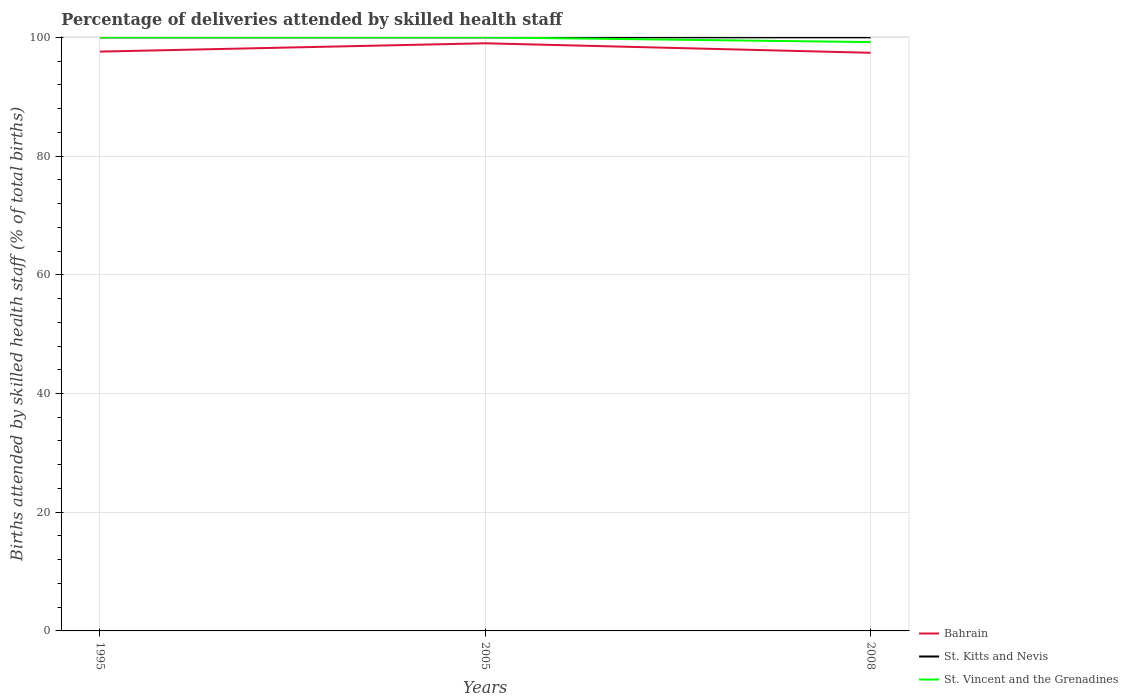How many different coloured lines are there?
Your answer should be compact. 3. Does the line corresponding to St. Kitts and Nevis intersect with the line corresponding to St. Vincent and the Grenadines?
Your answer should be compact. Yes. Across all years, what is the maximum percentage of births attended by skilled health staff in St. Vincent and the Grenadines?
Offer a terse response. 99.2. In which year was the percentage of births attended by skilled health staff in St. Vincent and the Grenadines maximum?
Ensure brevity in your answer.  2008. What is the total percentage of births attended by skilled health staff in Bahrain in the graph?
Give a very brief answer. -1.4. What is the difference between the highest and the second highest percentage of births attended by skilled health staff in St. Vincent and the Grenadines?
Keep it short and to the point. 0.8. What is the difference between the highest and the lowest percentage of births attended by skilled health staff in St. Vincent and the Grenadines?
Offer a terse response. 2. How many lines are there?
Give a very brief answer. 3. How many years are there in the graph?
Keep it short and to the point. 3. What is the difference between two consecutive major ticks on the Y-axis?
Your answer should be very brief. 20. Does the graph contain any zero values?
Ensure brevity in your answer.  No. Does the graph contain grids?
Offer a terse response. Yes. Where does the legend appear in the graph?
Your answer should be compact. Bottom right. What is the title of the graph?
Your answer should be compact. Percentage of deliveries attended by skilled health staff. Does "Turkey" appear as one of the legend labels in the graph?
Offer a very short reply. No. What is the label or title of the Y-axis?
Provide a succinct answer. Births attended by skilled health staff (% of total births). What is the Births attended by skilled health staff (% of total births) in Bahrain in 1995?
Your answer should be very brief. 97.6. What is the Births attended by skilled health staff (% of total births) in St. Vincent and the Grenadines in 1995?
Give a very brief answer. 100. What is the Births attended by skilled health staff (% of total births) of Bahrain in 2005?
Provide a short and direct response. 99. What is the Births attended by skilled health staff (% of total births) of St. Kitts and Nevis in 2005?
Offer a terse response. 100. What is the Births attended by skilled health staff (% of total births) in St. Vincent and the Grenadines in 2005?
Your answer should be compact. 100. What is the Births attended by skilled health staff (% of total births) in Bahrain in 2008?
Provide a short and direct response. 97.4. What is the Births attended by skilled health staff (% of total births) of St. Vincent and the Grenadines in 2008?
Offer a very short reply. 99.2. Across all years, what is the minimum Births attended by skilled health staff (% of total births) in Bahrain?
Provide a short and direct response. 97.4. Across all years, what is the minimum Births attended by skilled health staff (% of total births) of St. Vincent and the Grenadines?
Your response must be concise. 99.2. What is the total Births attended by skilled health staff (% of total births) of Bahrain in the graph?
Offer a very short reply. 294. What is the total Births attended by skilled health staff (% of total births) in St. Kitts and Nevis in the graph?
Make the answer very short. 300. What is the total Births attended by skilled health staff (% of total births) in St. Vincent and the Grenadines in the graph?
Provide a succinct answer. 299.2. What is the difference between the Births attended by skilled health staff (% of total births) in Bahrain in 1995 and that in 2005?
Make the answer very short. -1.4. What is the difference between the Births attended by skilled health staff (% of total births) in St. Kitts and Nevis in 1995 and that in 2005?
Make the answer very short. 0. What is the difference between the Births attended by skilled health staff (% of total births) of St. Vincent and the Grenadines in 1995 and that in 2005?
Your answer should be very brief. 0. What is the difference between the Births attended by skilled health staff (% of total births) in Bahrain in 1995 and that in 2008?
Give a very brief answer. 0.2. What is the difference between the Births attended by skilled health staff (% of total births) in St. Kitts and Nevis in 1995 and that in 2008?
Make the answer very short. 0. What is the difference between the Births attended by skilled health staff (% of total births) of Bahrain in 2005 and that in 2008?
Your answer should be very brief. 1.6. What is the difference between the Births attended by skilled health staff (% of total births) of Bahrain in 1995 and the Births attended by skilled health staff (% of total births) of St. Kitts and Nevis in 2005?
Your response must be concise. -2.4. What is the difference between the Births attended by skilled health staff (% of total births) of Bahrain in 1995 and the Births attended by skilled health staff (% of total births) of St. Vincent and the Grenadines in 2005?
Your answer should be compact. -2.4. What is the difference between the Births attended by skilled health staff (% of total births) of St. Kitts and Nevis in 1995 and the Births attended by skilled health staff (% of total births) of St. Vincent and the Grenadines in 2008?
Offer a very short reply. 0.8. What is the average Births attended by skilled health staff (% of total births) in St. Kitts and Nevis per year?
Ensure brevity in your answer.  100. What is the average Births attended by skilled health staff (% of total births) in St. Vincent and the Grenadines per year?
Provide a short and direct response. 99.73. In the year 1995, what is the difference between the Births attended by skilled health staff (% of total births) in Bahrain and Births attended by skilled health staff (% of total births) in St. Vincent and the Grenadines?
Keep it short and to the point. -2.4. In the year 2008, what is the difference between the Births attended by skilled health staff (% of total births) of Bahrain and Births attended by skilled health staff (% of total births) of St. Kitts and Nevis?
Ensure brevity in your answer.  -2.6. In the year 2008, what is the difference between the Births attended by skilled health staff (% of total births) in St. Kitts and Nevis and Births attended by skilled health staff (% of total births) in St. Vincent and the Grenadines?
Keep it short and to the point. 0.8. What is the ratio of the Births attended by skilled health staff (% of total births) of Bahrain in 1995 to that in 2005?
Offer a terse response. 0.99. What is the ratio of the Births attended by skilled health staff (% of total births) in St. Vincent and the Grenadines in 1995 to that in 2005?
Ensure brevity in your answer.  1. What is the ratio of the Births attended by skilled health staff (% of total births) in St. Vincent and the Grenadines in 1995 to that in 2008?
Keep it short and to the point. 1.01. What is the ratio of the Births attended by skilled health staff (% of total births) in Bahrain in 2005 to that in 2008?
Keep it short and to the point. 1.02. What is the ratio of the Births attended by skilled health staff (% of total births) of St. Vincent and the Grenadines in 2005 to that in 2008?
Provide a short and direct response. 1.01. What is the difference between the highest and the lowest Births attended by skilled health staff (% of total births) in St. Kitts and Nevis?
Keep it short and to the point. 0. 